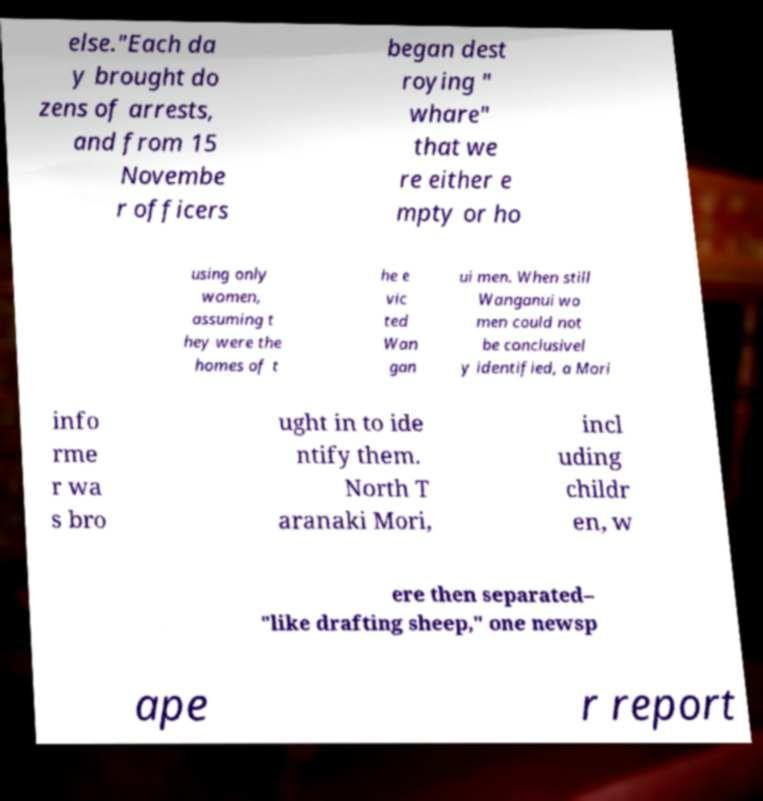Please identify and transcribe the text found in this image. else."Each da y brought do zens of arrests, and from 15 Novembe r officers began dest roying " whare" that we re either e mpty or ho using only women, assuming t hey were the homes of t he e vic ted Wan gan ui men. When still Wanganui wo men could not be conclusivel y identified, a Mori info rme r wa s bro ught in to ide ntify them. North T aranaki Mori, incl uding childr en, w ere then separated– "like drafting sheep," one newsp ape r report 